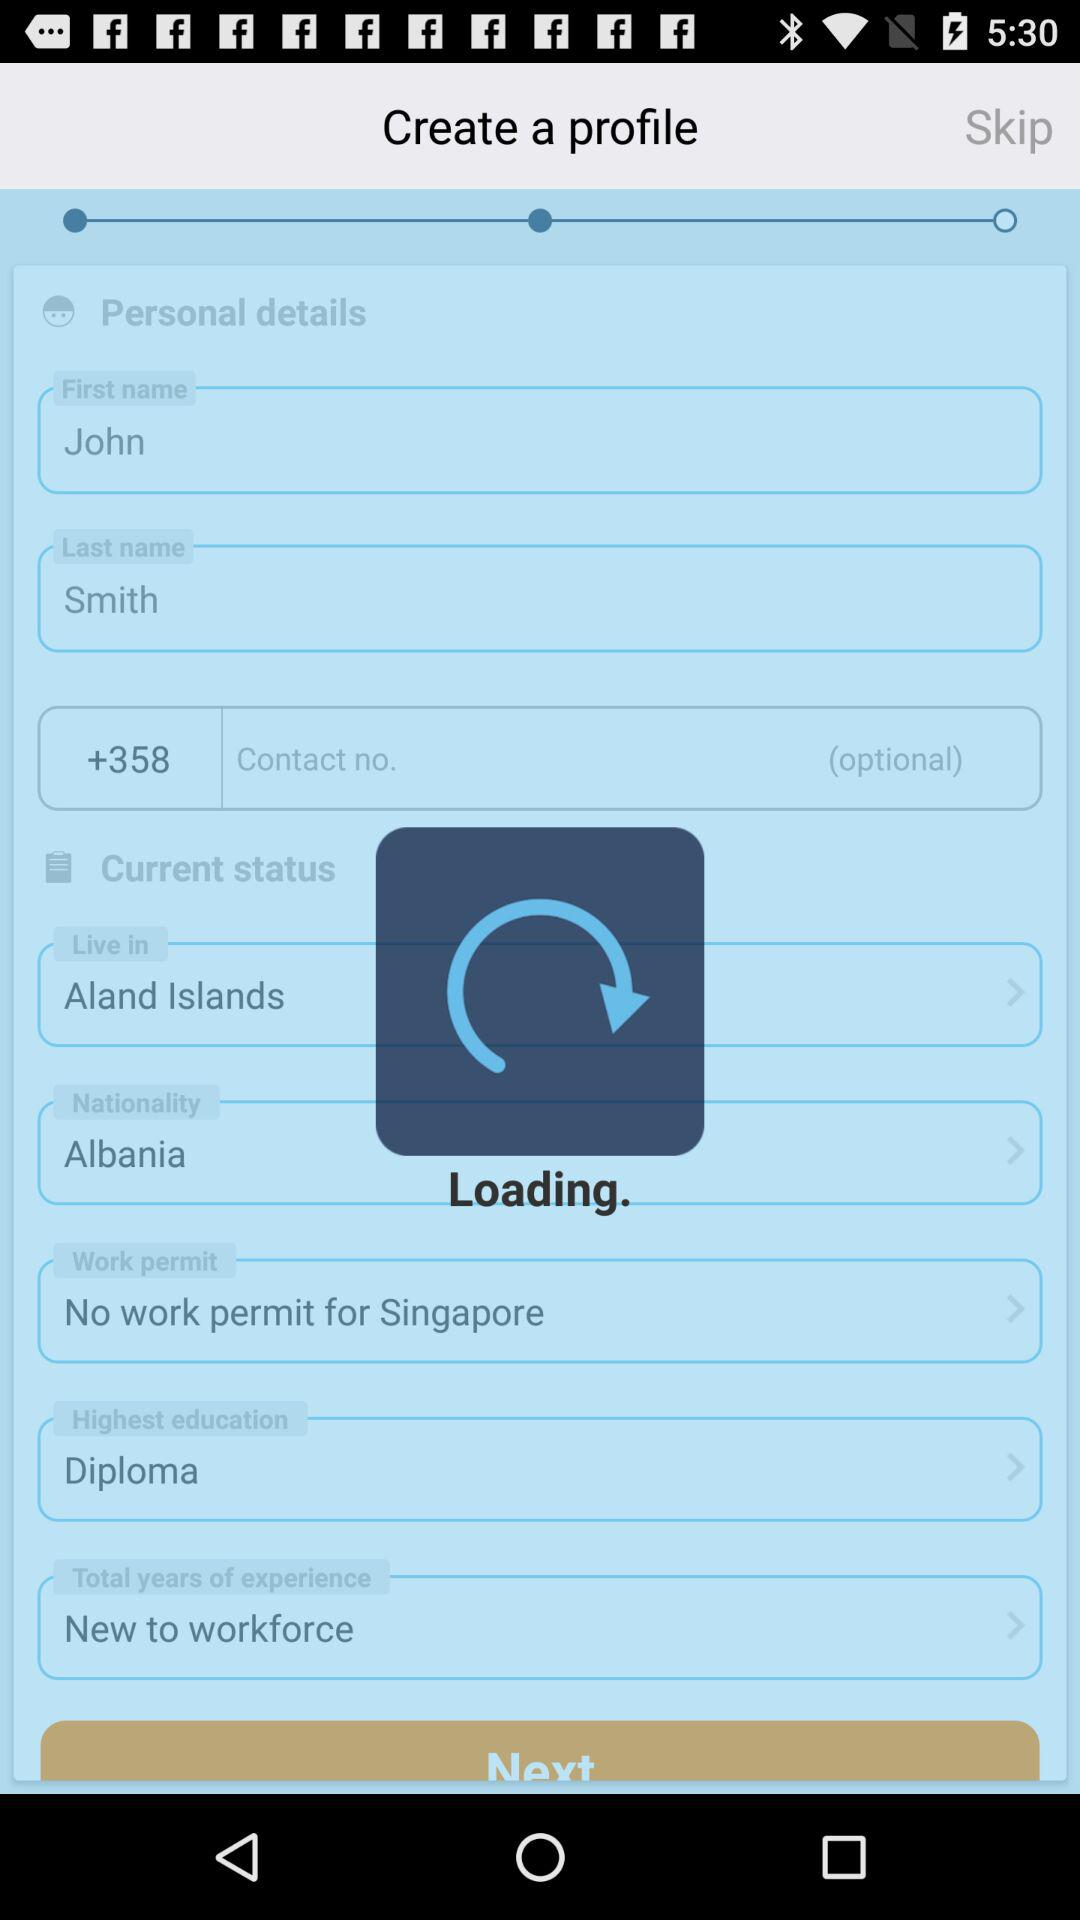What is the nationality of John Smith? The nationality of John Smith is Albania. 